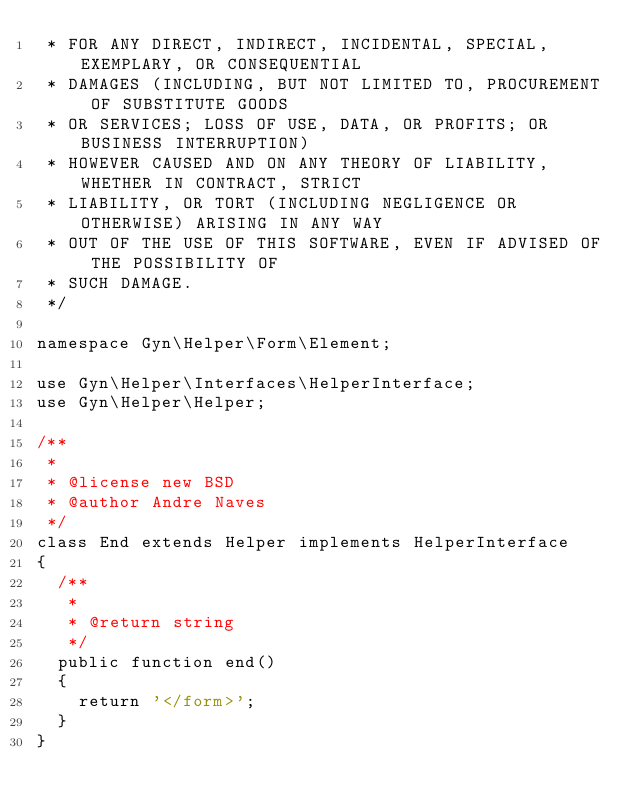<code> <loc_0><loc_0><loc_500><loc_500><_PHP_> * FOR ANY DIRECT, INDIRECT, INCIDENTAL, SPECIAL, EXEMPLARY, OR CONSEQUENTIAL
 * DAMAGES (INCLUDING, BUT NOT LIMITED TO, PROCUREMENT OF SUBSTITUTE GOODS
 * OR SERVICES; LOSS OF USE, DATA, OR PROFITS; OR BUSINESS INTERRUPTION)
 * HOWEVER CAUSED AND ON ANY THEORY OF LIABILITY, WHETHER IN CONTRACT, STRICT
 * LIABILITY, OR TORT (INCLUDING NEGLIGENCE OR OTHERWISE) ARISING IN ANY WAY
 * OUT OF THE USE OF THIS SOFTWARE, EVEN IF ADVISED OF THE POSSIBILITY OF
 * SUCH DAMAGE.
 */

namespace Gyn\Helper\Form\Element;

use Gyn\Helper\Interfaces\HelperInterface;
use Gyn\Helper\Helper;

/**
 *
 * @license new BSD
 * @author Andre Naves
 */
class End extends Helper implements HelperInterface
{
	/**
	 * 
	 * @return string
	 */
	public function end()
	{
		return '</form>';
	}
}</code> 